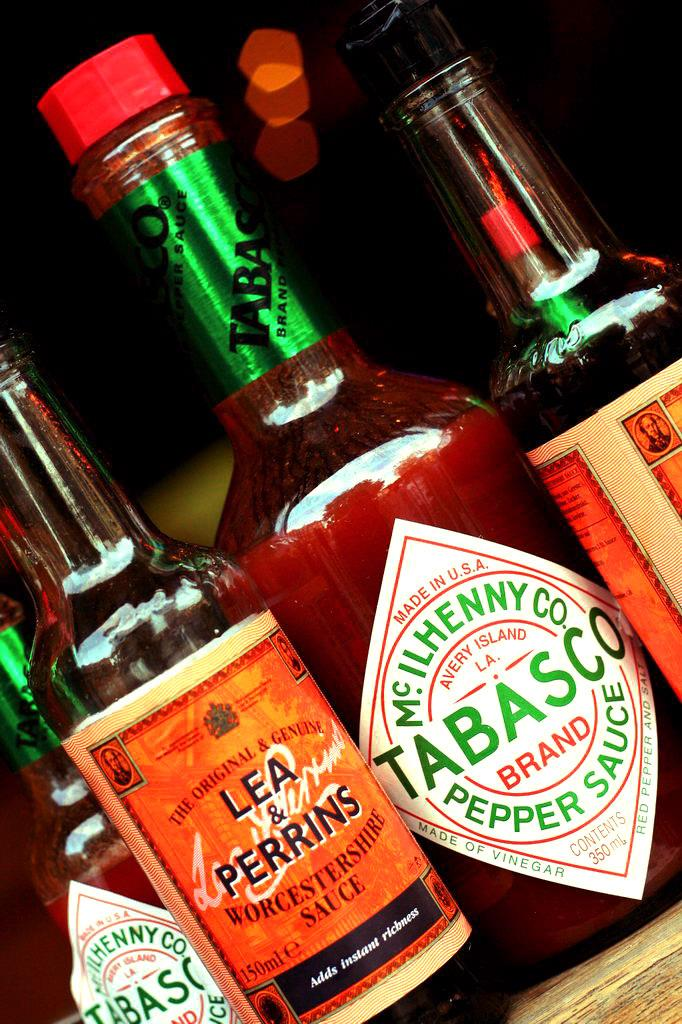<image>
Present a compact description of the photo's key features. A number of different Tabasco and Lea & Perrins sauces are displayed. 